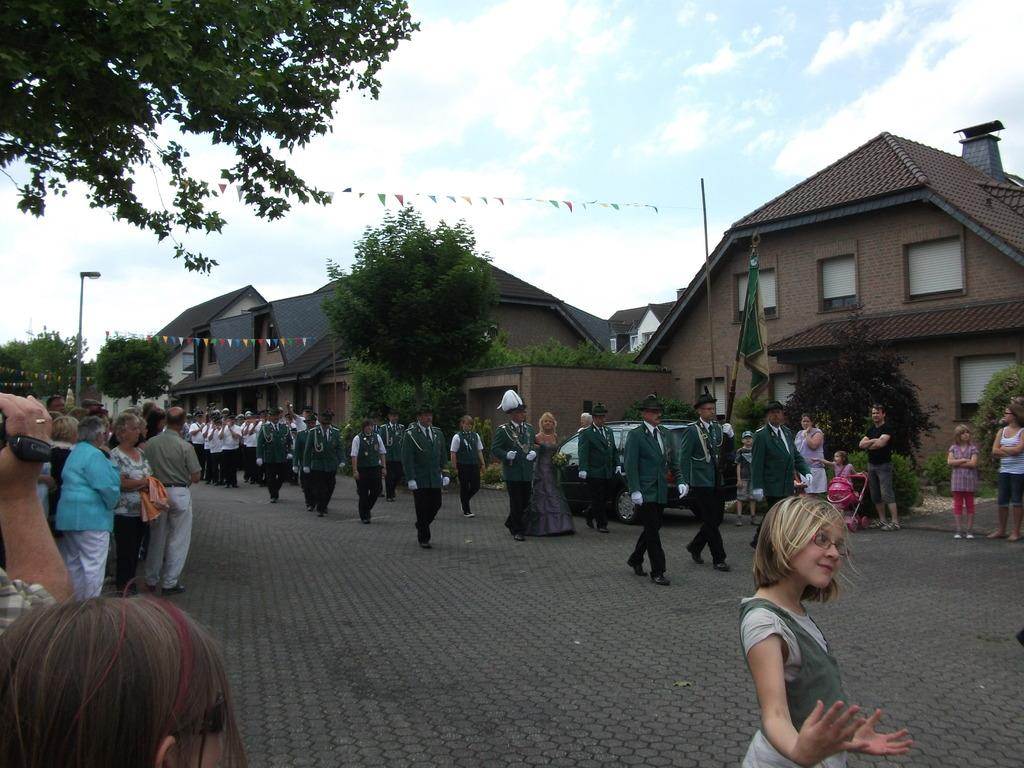What are the people in the image doing? There are persons standing and walking in the image. What can be seen in the distance behind the people? There are buildings and trees in the background of the image. How would you describe the weather in the image? The sky is cloudy in the image. What objects are present in the image besides the people and buildings? There are poles in the image. What type of dinosaurs can be seen roaming in the image? There are no dinosaurs present in the image; it features people, buildings, trees, and poles. 